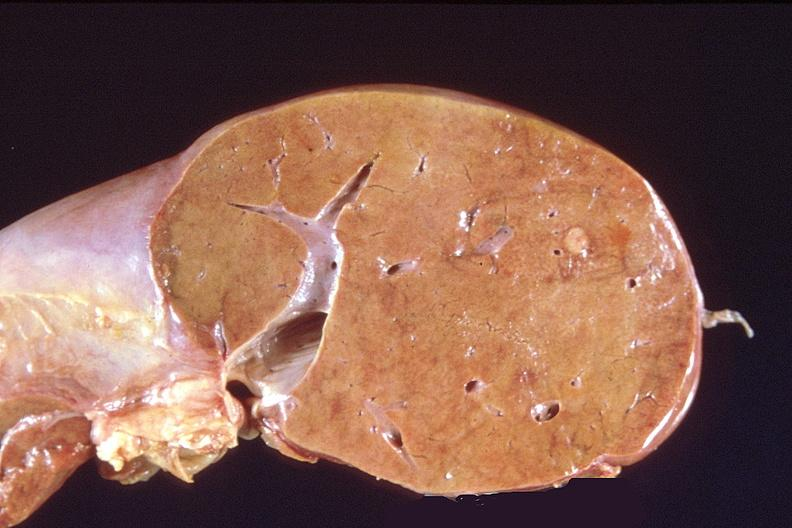s view of head with scalp present?
Answer the question using a single word or phrase. No 